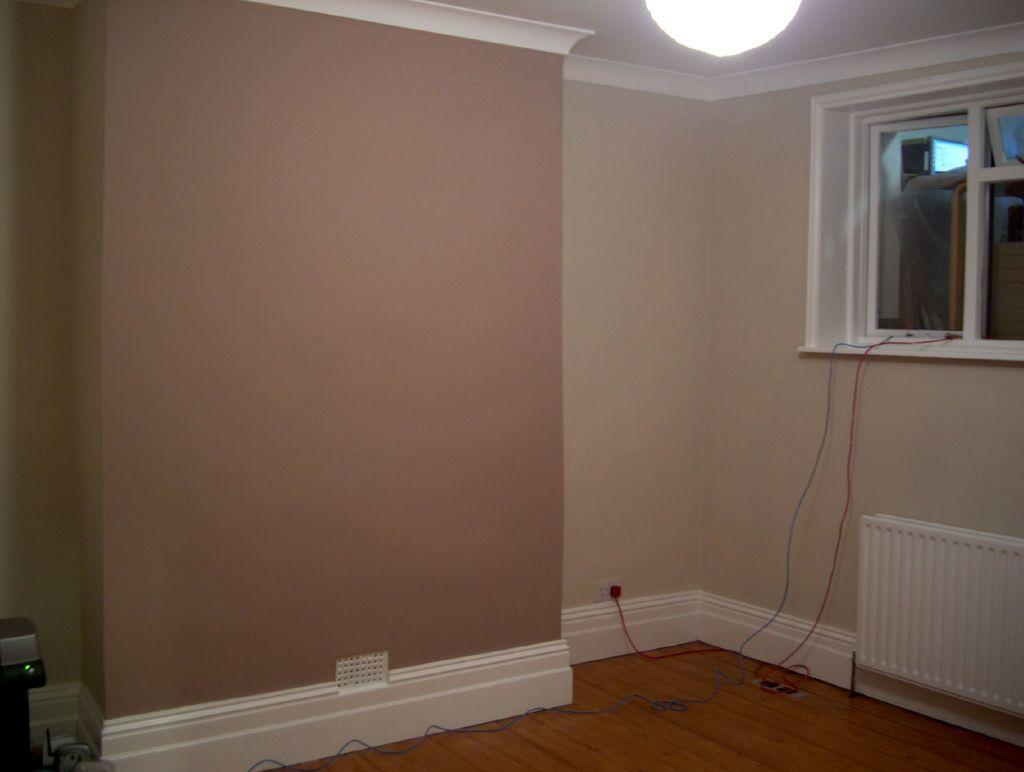What part of a building is shown in the image? The image shows the inner part of a room. What can be seen in the background of the room? There is a glass window in the background. Is there any source of light visible in the image? Yes, a light is visible in the image. How would you describe the color of the wall in the room? The wall has a cream and brown color. What role does the actor play in the image? There is no actor present in the image; it shows the inner part of a room with a glass window, a light, and a wall with a cream and brown color. 